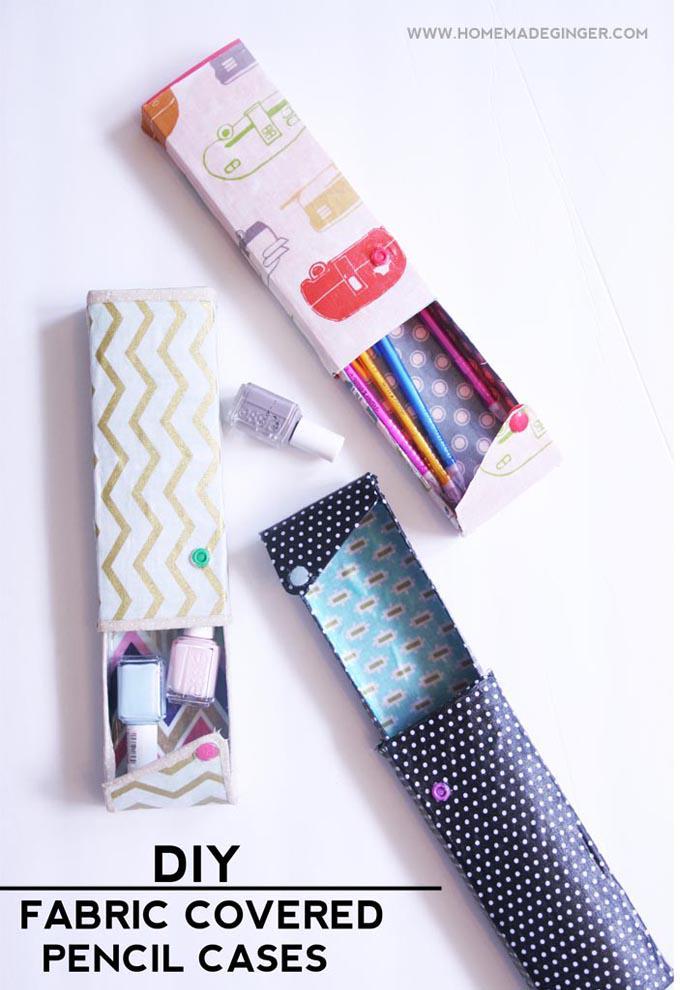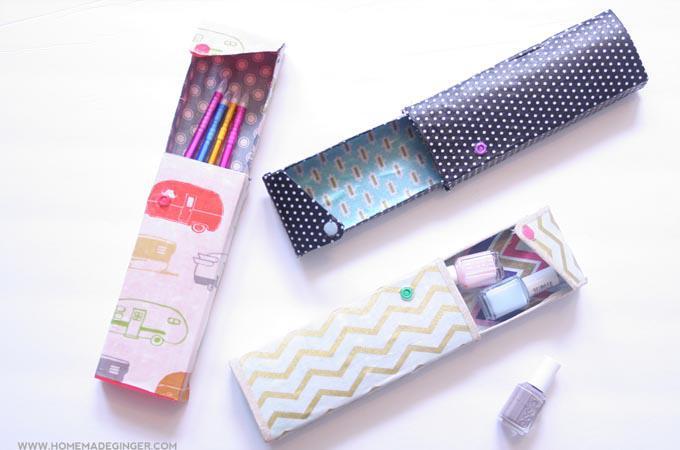The first image is the image on the left, the second image is the image on the right. For the images shown, is this caption "There is a zipper in the image on the right." true? Answer yes or no. No. 